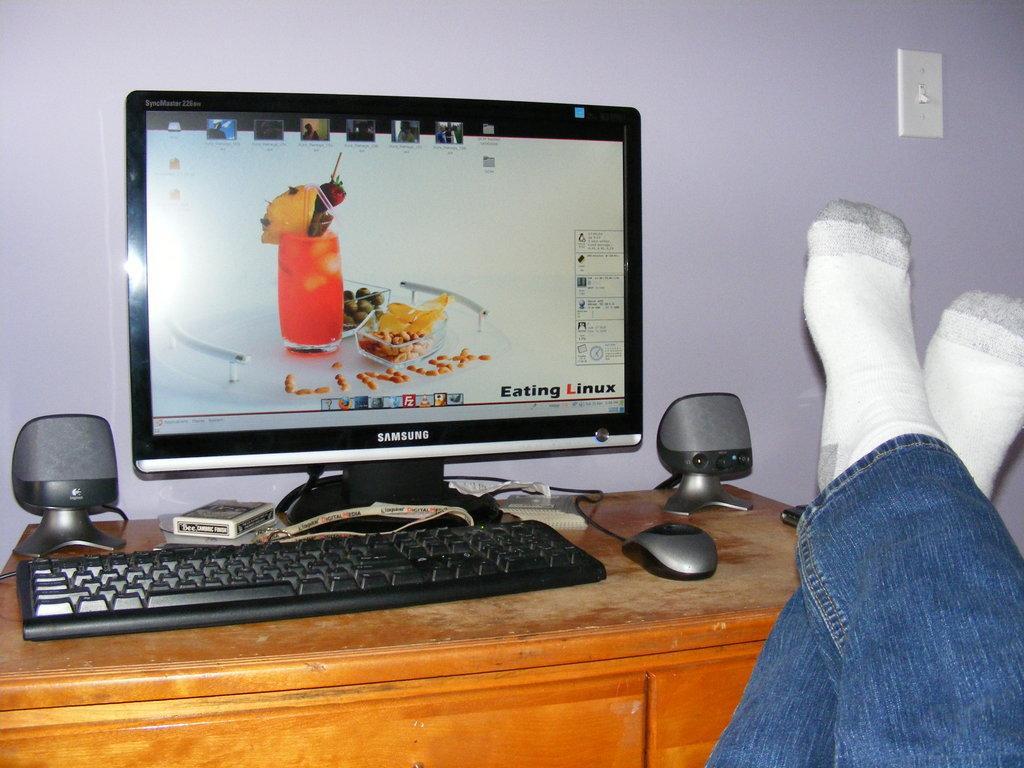What object is placed on the table in the image? There is a box on the table. What other items can be seen on the table? There are speakers, a mouse, a keyboard, and a monitor on the table. What might be used for input in the image? The mouse and keyboard on the table might be used for input. What is the table's appearance in terms of its legs? The table has legs with socks. Can you see any cherries on the table in the image? There are no cherries present on the table in the image. What type of beam is supporting the table in the image? There is no beam visible in the image; it only shows the table and its items. 